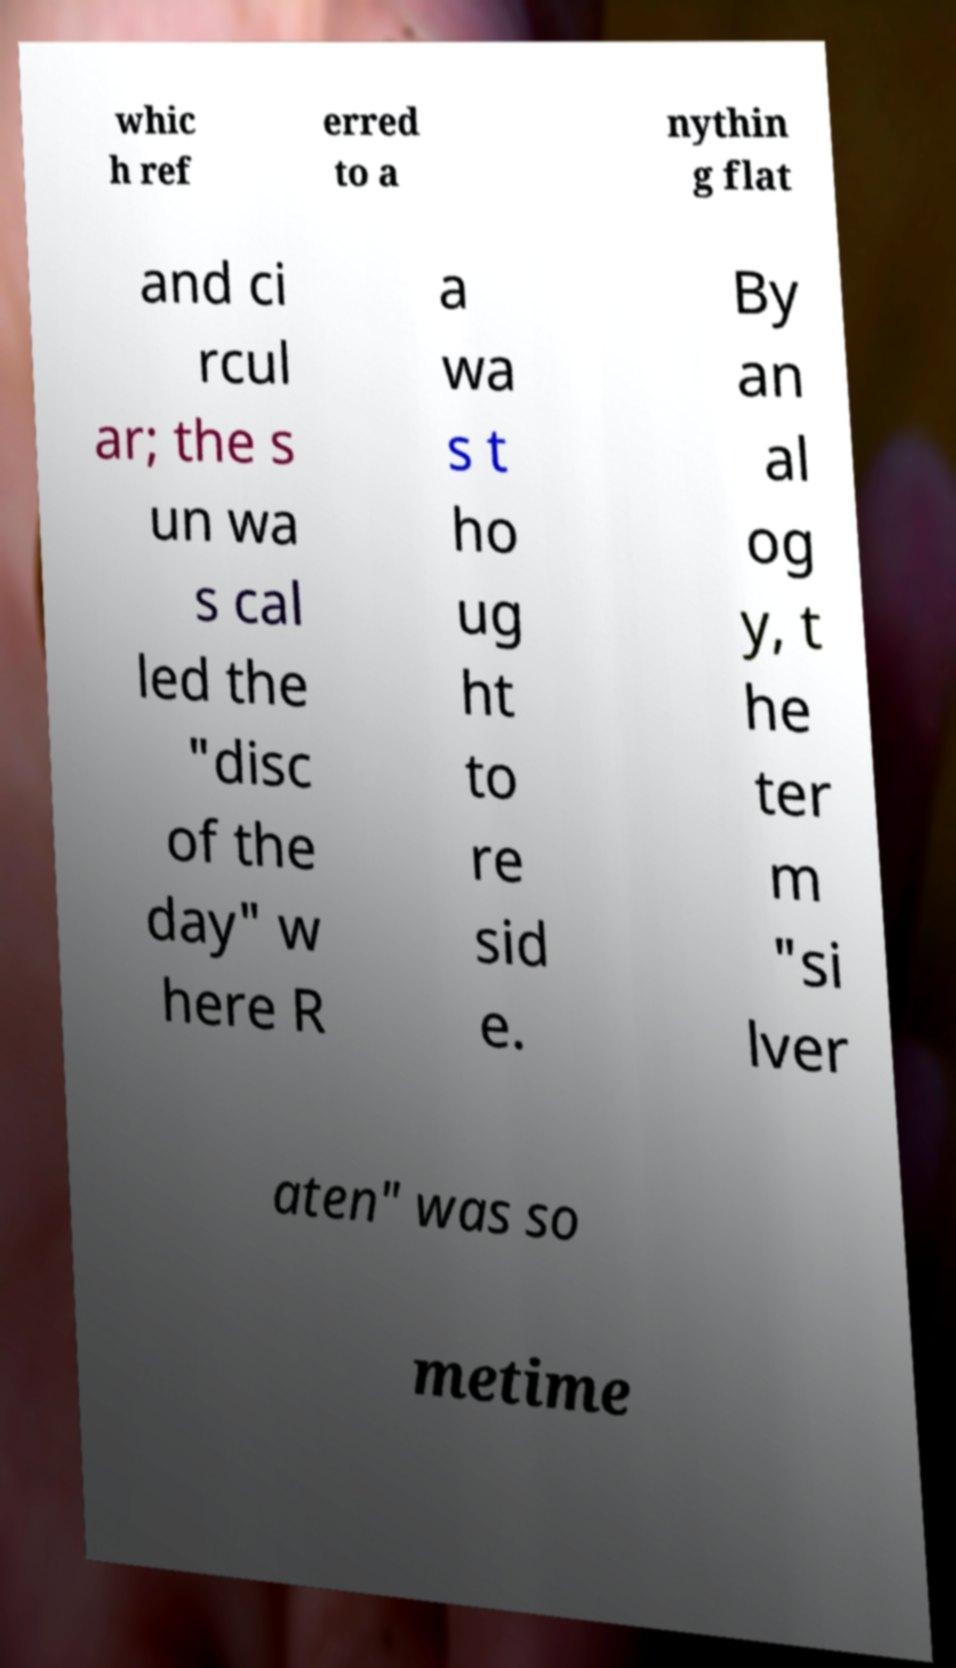Can you accurately transcribe the text from the provided image for me? whic h ref erred to a nythin g flat and ci rcul ar; the s un wa s cal led the "disc of the day" w here R a wa s t ho ug ht to re sid e. By an al og y, t he ter m "si lver aten" was so metime 